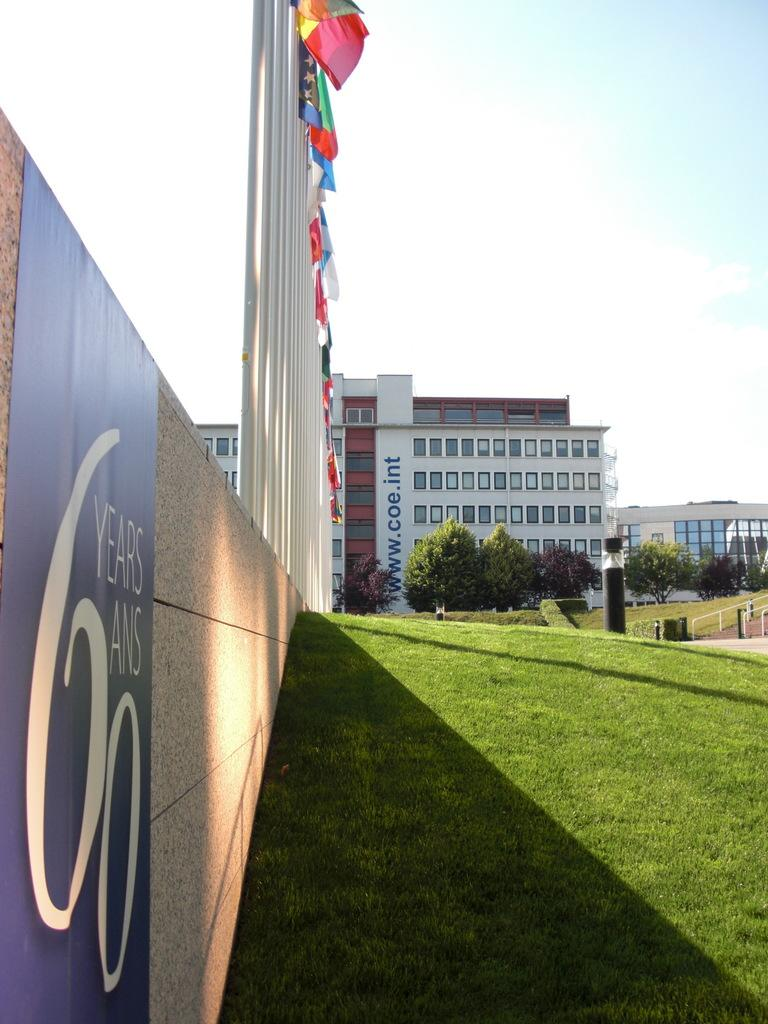Provide a one-sentence caption for the provided image. Outside an building with flags on poles lined up outside and a grass area with a wall and a banner reading 60 years. 